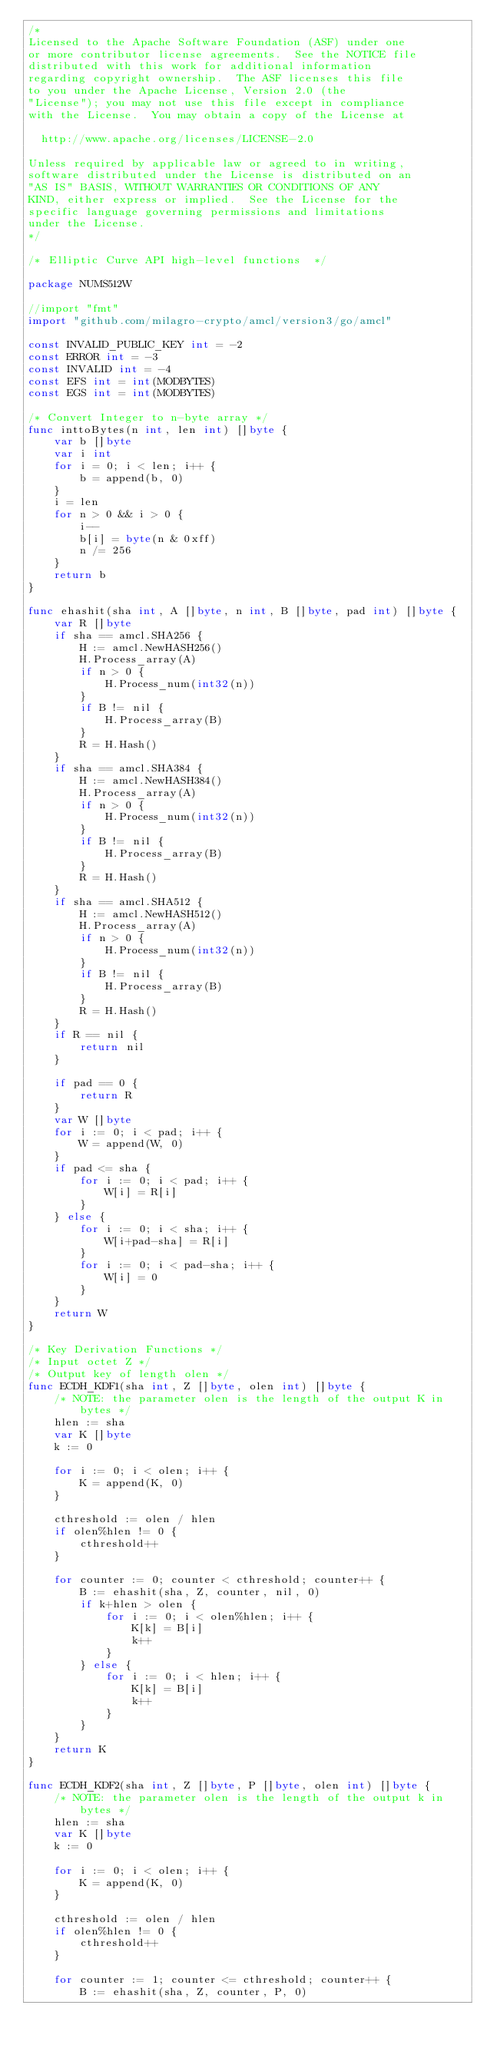<code> <loc_0><loc_0><loc_500><loc_500><_Go_>/*
Licensed to the Apache Software Foundation (ASF) under one
or more contributor license agreements.  See the NOTICE file
distributed with this work for additional information
regarding copyright ownership.  The ASF licenses this file
to you under the Apache License, Version 2.0 (the
"License"); you may not use this file except in compliance
with the License.  You may obtain a copy of the License at

  http://www.apache.org/licenses/LICENSE-2.0

Unless required by applicable law or agreed to in writing,
software distributed under the License is distributed on an
"AS IS" BASIS, WITHOUT WARRANTIES OR CONDITIONS OF ANY
KIND, either express or implied.  See the License for the
specific language governing permissions and limitations
under the License.
*/

/* Elliptic Curve API high-level functions  */

package NUMS512W

//import "fmt"
import "github.com/milagro-crypto/amcl/version3/go/amcl"

const INVALID_PUBLIC_KEY int = -2
const ERROR int = -3
const INVALID int = -4
const EFS int = int(MODBYTES)
const EGS int = int(MODBYTES)

/* Convert Integer to n-byte array */
func inttoBytes(n int, len int) []byte {
	var b []byte
	var i int
	for i = 0; i < len; i++ {
		b = append(b, 0)
	}
	i = len
	for n > 0 && i > 0 {
		i--
		b[i] = byte(n & 0xff)
		n /= 256
	}
	return b
}

func ehashit(sha int, A []byte, n int, B []byte, pad int) []byte {
	var R []byte
	if sha == amcl.SHA256 {
		H := amcl.NewHASH256()
		H.Process_array(A)
		if n > 0 {
			H.Process_num(int32(n))
		}
		if B != nil {
			H.Process_array(B)
		}
		R = H.Hash()
	}
	if sha == amcl.SHA384 {
		H := amcl.NewHASH384()
		H.Process_array(A)
		if n > 0 {
			H.Process_num(int32(n))
		}
		if B != nil {
			H.Process_array(B)
		}
		R = H.Hash()
	}
	if sha == amcl.SHA512 {
		H := amcl.NewHASH512()
		H.Process_array(A)
		if n > 0 {
			H.Process_num(int32(n))
		}
		if B != nil {
			H.Process_array(B)
		}
		R = H.Hash()
	}
	if R == nil {
		return nil
	}

	if pad == 0 {
		return R
	}
	var W []byte
	for i := 0; i < pad; i++ {
		W = append(W, 0)
	}
	if pad <= sha {
		for i := 0; i < pad; i++ {
			W[i] = R[i]
		}
	} else {
		for i := 0; i < sha; i++ {
			W[i+pad-sha] = R[i]
		}
		for i := 0; i < pad-sha; i++ {
			W[i] = 0
		}
	}
	return W
}

/* Key Derivation Functions */
/* Input octet Z */
/* Output key of length olen */
func ECDH_KDF1(sha int, Z []byte, olen int) []byte {
	/* NOTE: the parameter olen is the length of the output K in bytes */
	hlen := sha
	var K []byte
	k := 0

	for i := 0; i < olen; i++ {
		K = append(K, 0)
	}

	cthreshold := olen / hlen
	if olen%hlen != 0 {
		cthreshold++
	}

	for counter := 0; counter < cthreshold; counter++ {
		B := ehashit(sha, Z, counter, nil, 0)
		if k+hlen > olen {
			for i := 0; i < olen%hlen; i++ {
				K[k] = B[i]
				k++
			}
		} else {
			for i := 0; i < hlen; i++ {
				K[k] = B[i]
				k++
			}
		}
	}
	return K
}

func ECDH_KDF2(sha int, Z []byte, P []byte, olen int) []byte {
	/* NOTE: the parameter olen is the length of the output k in bytes */
	hlen := sha
	var K []byte
	k := 0

	for i := 0; i < olen; i++ {
		K = append(K, 0)
	}

	cthreshold := olen / hlen
	if olen%hlen != 0 {
		cthreshold++
	}

	for counter := 1; counter <= cthreshold; counter++ {
		B := ehashit(sha, Z, counter, P, 0)</code> 